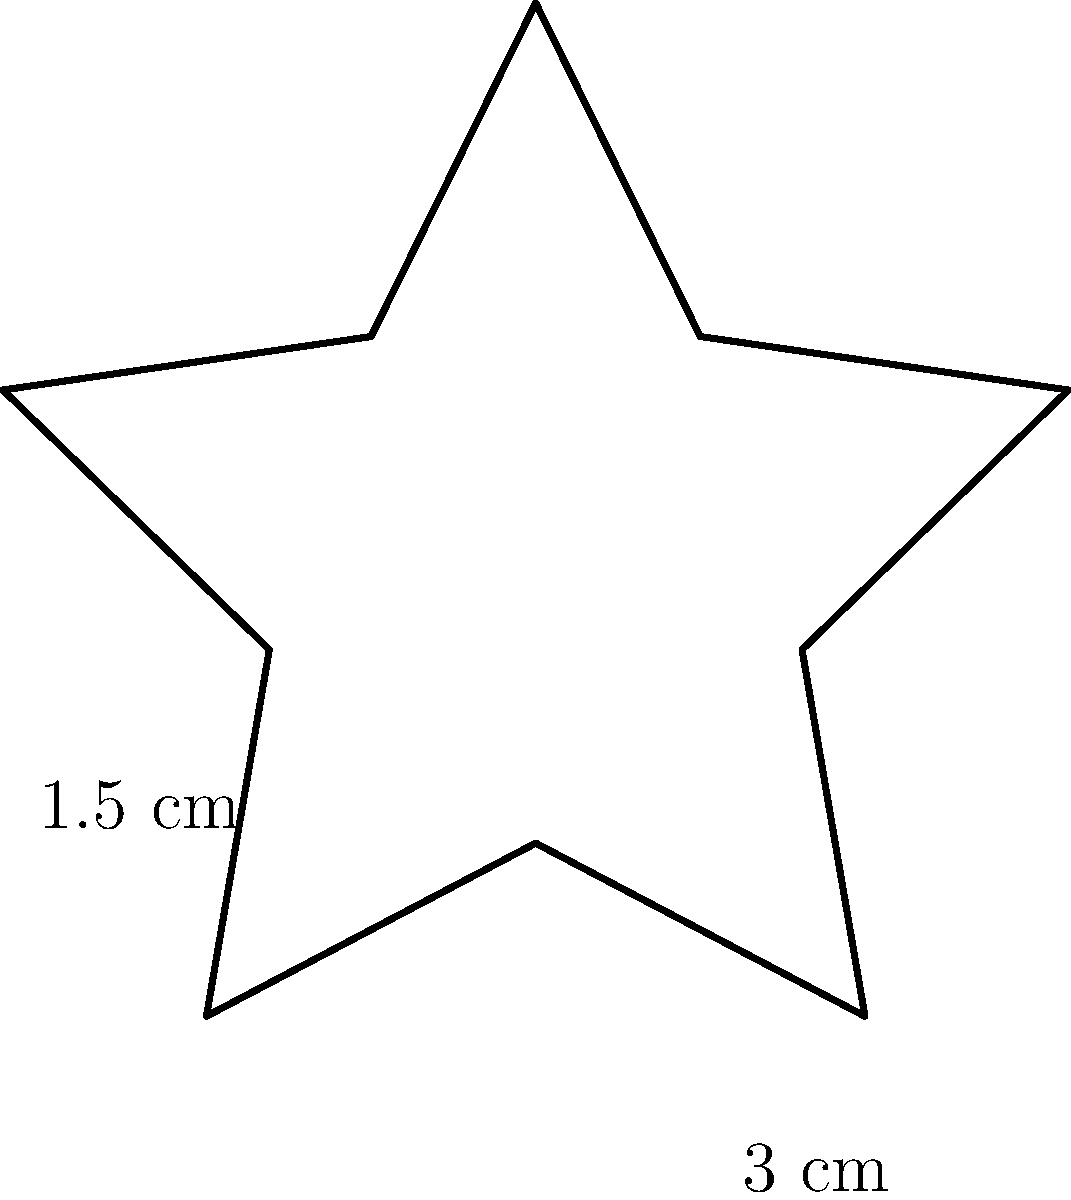As an actor preparing for a role as an award-winning artist, you're studying the emotional significance of a star-shaped award plaque. The plaque's design alternates between longer and shorter points, with the longer points measuring 3 cm from the center and the shorter points measuring 1.5 cm. If the plaque has 5 points in total, what is its perimeter? How might the size and shape of this award influence your character's emotional state? Let's approach this step-by-step, considering both the mathematical and emotional aspects:

1) First, we need to calculate the perimeter of the star. The star has 10 sides in total (5 longer and 5 shorter).

2) To find the length of each side, we can use the formula for the chord length between two points on a circle:

   $chord = 2r \sin(\frac{\theta}{2})$

   where $r$ is the radius and $\theta$ is the central angle between the points.

3) The central angle between each point is $\frac{2\pi}{10} = \frac{\pi}{5}$.

4) For the longer sides:
   $length_{long} = 2 \cdot 3 \cdot \sin(\frac{\pi}{10}) = 6 \sin(\frac{\pi}{10})$ cm

5) For the shorter sides:
   $length_{short} = 2 \cdot 1.5 \cdot \sin(\frac{\pi}{10}) = 3 \sin(\frac{\pi}{10})$ cm

6) The perimeter is the sum of all sides:
   $perimeter = 5 \cdot length_{long} + 5 \cdot length_{short}$
               $= 5 \cdot 6 \sin(\frac{\pi}{10}) + 5 \cdot 3 \sin(\frac{\pi}{10})$
               $= 45 \sin(\frac{\pi}{10})$ cm

7) Calculating this value: $45 \sin(\frac{\pi}{10}) \approx 13.76$ cm

From an emotional perspective, the star shape symbolizes excellence and achievement. The alternating long and short points could represent the ups and downs of an artistic career. The relatively small size (perimeter of about 13.76 cm) might make the award feel intimate and personal, possibly evoking feelings of pride mixed with humility. The character might feel a deep connection to this tangible representation of their hard work and talent.
Answer: $45 \sin(\frac{\pi}{10}) \approx 13.76$ cm 